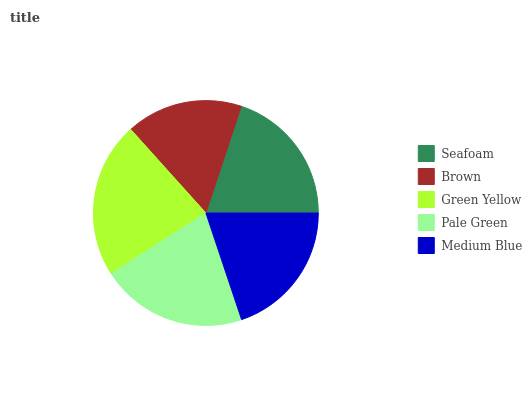Is Brown the minimum?
Answer yes or no. Yes. Is Green Yellow the maximum?
Answer yes or no. Yes. Is Green Yellow the minimum?
Answer yes or no. No. Is Brown the maximum?
Answer yes or no. No. Is Green Yellow greater than Brown?
Answer yes or no. Yes. Is Brown less than Green Yellow?
Answer yes or no. Yes. Is Brown greater than Green Yellow?
Answer yes or no. No. Is Green Yellow less than Brown?
Answer yes or no. No. Is Seafoam the high median?
Answer yes or no. Yes. Is Seafoam the low median?
Answer yes or no. Yes. Is Green Yellow the high median?
Answer yes or no. No. Is Green Yellow the low median?
Answer yes or no. No. 